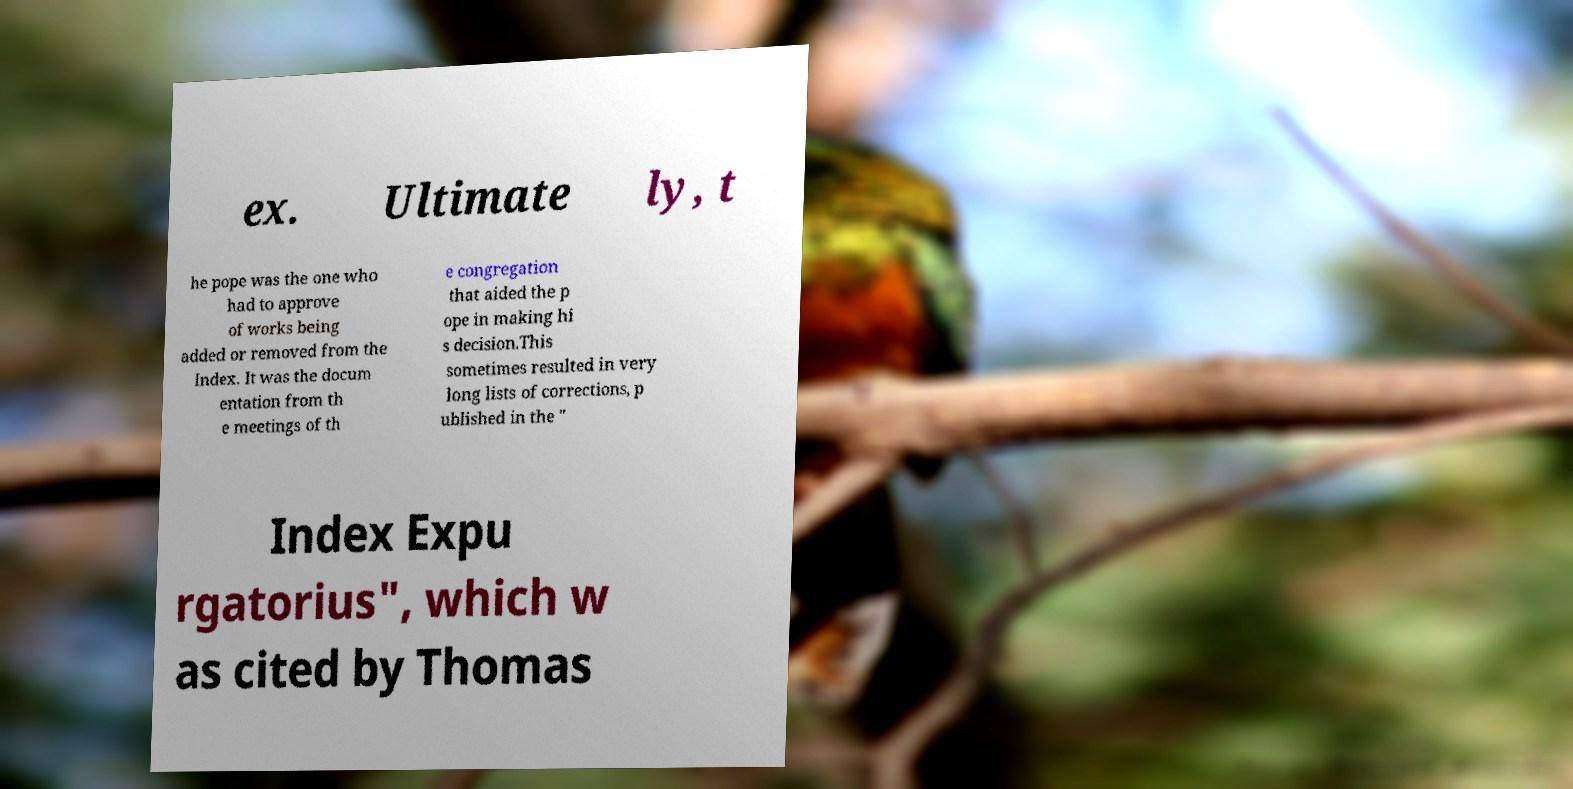What messages or text are displayed in this image? I need them in a readable, typed format. ex. Ultimate ly, t he pope was the one who had to approve of works being added or removed from the Index. It was the docum entation from th e meetings of th e congregation that aided the p ope in making hi s decision.This sometimes resulted in very long lists of corrections, p ublished in the " Index Expu rgatorius", which w as cited by Thomas 